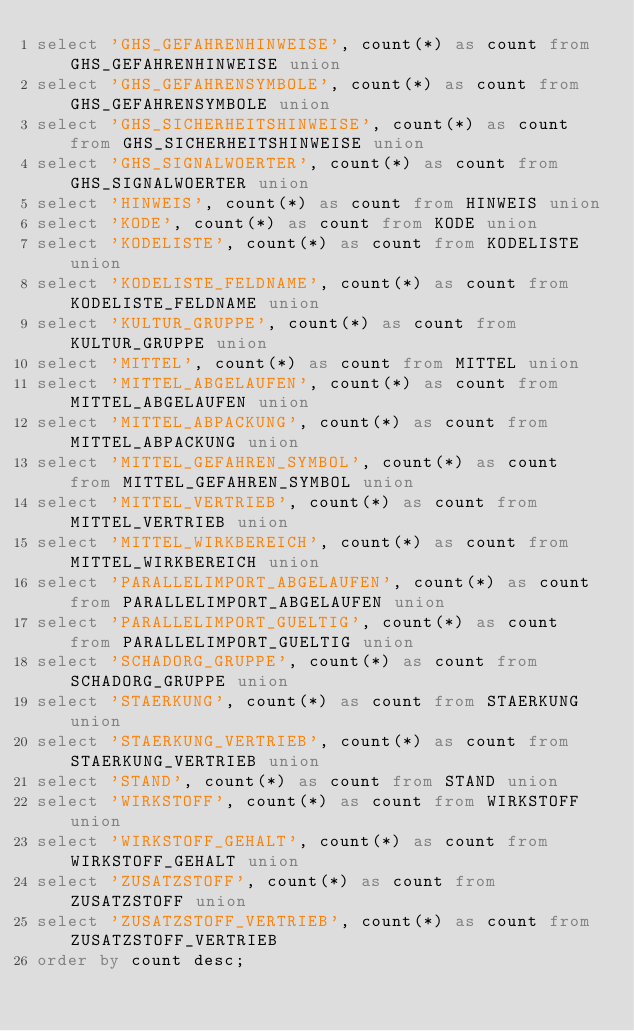Convert code to text. <code><loc_0><loc_0><loc_500><loc_500><_SQL_>select 'GHS_GEFAHRENHINWEISE', count(*) as count from GHS_GEFAHRENHINWEISE union
select 'GHS_GEFAHRENSYMBOLE', count(*) as count from GHS_GEFAHRENSYMBOLE union
select 'GHS_SICHERHEITSHINWEISE', count(*) as count from GHS_SICHERHEITSHINWEISE union
select 'GHS_SIGNALWOERTER', count(*) as count from GHS_SIGNALWOERTER union
select 'HINWEIS', count(*) as count from HINWEIS union
select 'KODE', count(*) as count from KODE union
select 'KODELISTE', count(*) as count from KODELISTE union
select 'KODELISTE_FELDNAME', count(*) as count from KODELISTE_FELDNAME union
select 'KULTUR_GRUPPE', count(*) as count from KULTUR_GRUPPE union
select 'MITTEL', count(*) as count from MITTEL union
select 'MITTEL_ABGELAUFEN', count(*) as count from MITTEL_ABGELAUFEN union
select 'MITTEL_ABPACKUNG', count(*) as count from MITTEL_ABPACKUNG union
select 'MITTEL_GEFAHREN_SYMBOL', count(*) as count from MITTEL_GEFAHREN_SYMBOL union
select 'MITTEL_VERTRIEB', count(*) as count from MITTEL_VERTRIEB union
select 'MITTEL_WIRKBEREICH', count(*) as count from MITTEL_WIRKBEREICH union
select 'PARALLELIMPORT_ABGELAUFEN', count(*) as count from PARALLELIMPORT_ABGELAUFEN union
select 'PARALLELIMPORT_GUELTIG', count(*) as count from PARALLELIMPORT_GUELTIG union
select 'SCHADORG_GRUPPE', count(*) as count from SCHADORG_GRUPPE union
select 'STAERKUNG', count(*) as count from STAERKUNG union
select 'STAERKUNG_VERTRIEB', count(*) as count from STAERKUNG_VERTRIEB union
select 'STAND', count(*) as count from STAND union
select 'WIRKSTOFF', count(*) as count from WIRKSTOFF union
select 'WIRKSTOFF_GEHALT', count(*) as count from WIRKSTOFF_GEHALT union
select 'ZUSATZSTOFF', count(*) as count from ZUSATZSTOFF union
select 'ZUSATZSTOFF_VERTRIEB', count(*) as count from ZUSATZSTOFF_VERTRIEB
order by count desc;
</code> 